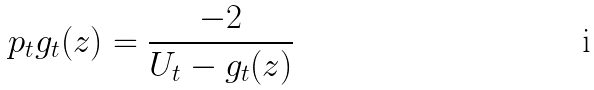Convert formula to latex. <formula><loc_0><loc_0><loc_500><loc_500>\ p _ { t } g _ { t } ( z ) = \frac { - 2 } { U _ { t } - g _ { t } ( z ) }</formula> 